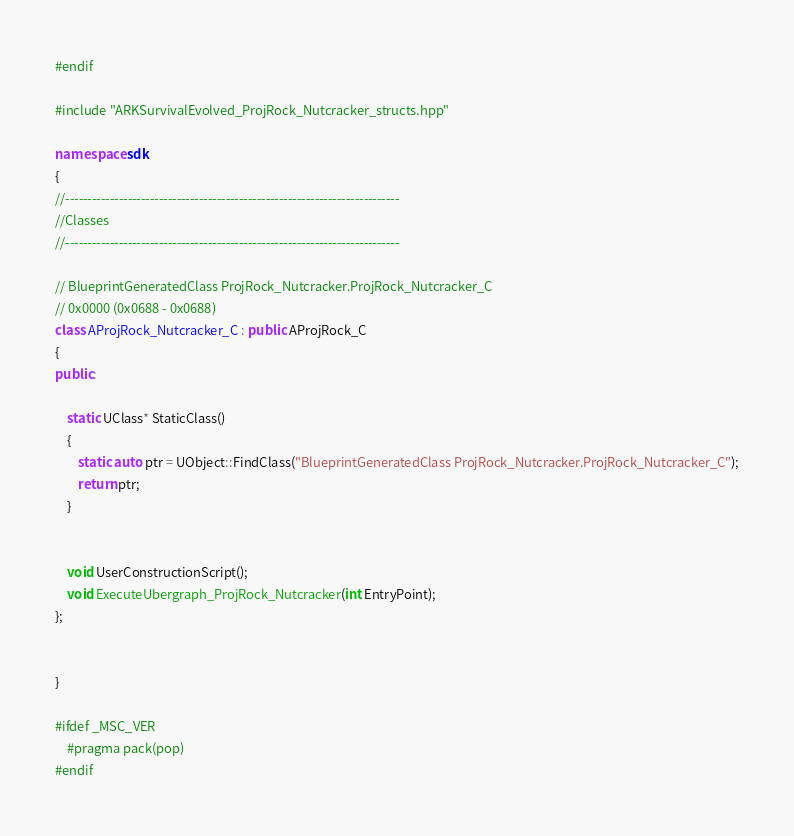Convert code to text. <code><loc_0><loc_0><loc_500><loc_500><_C++_>#endif

#include "ARKSurvivalEvolved_ProjRock_Nutcracker_structs.hpp"

namespace sdk
{
//---------------------------------------------------------------------------
//Classes
//---------------------------------------------------------------------------

// BlueprintGeneratedClass ProjRock_Nutcracker.ProjRock_Nutcracker_C
// 0x0000 (0x0688 - 0x0688)
class AProjRock_Nutcracker_C : public AProjRock_C
{
public:

	static UClass* StaticClass()
	{
		static auto ptr = UObject::FindClass("BlueprintGeneratedClass ProjRock_Nutcracker.ProjRock_Nutcracker_C");
		return ptr;
	}


	void UserConstructionScript();
	void ExecuteUbergraph_ProjRock_Nutcracker(int EntryPoint);
};


}

#ifdef _MSC_VER
	#pragma pack(pop)
#endif
</code> 